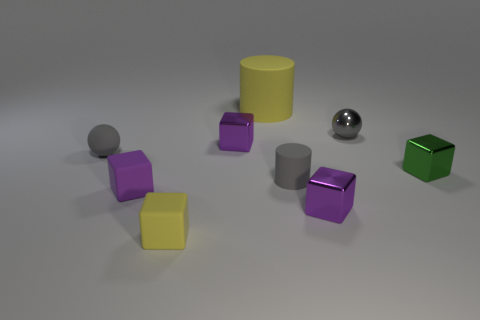What number of yellow objects are the same size as the yellow rubber block?
Make the answer very short. 0. Does the object that is left of the tiny purple rubber cube have the same size as the metal thing that is left of the big yellow object?
Your answer should be compact. Yes. The purple object that is in front of the green block and on the left side of the yellow cylinder has what shape?
Keep it short and to the point. Cube. Are there any tiny spheres that have the same color as the big matte cylinder?
Keep it short and to the point. No. Is there a gray sphere?
Keep it short and to the point. Yes. There is a tiny ball that is behind the small matte sphere; what is its color?
Provide a succinct answer. Gray. Does the rubber ball have the same size as the purple thing to the right of the big object?
Give a very brief answer. Yes. There is a shiny block that is behind the purple rubber block and on the left side of the green cube; what is its size?
Your answer should be compact. Small. Is there a gray ball made of the same material as the tiny yellow object?
Keep it short and to the point. Yes. There is a small green shiny thing; what shape is it?
Make the answer very short. Cube. 